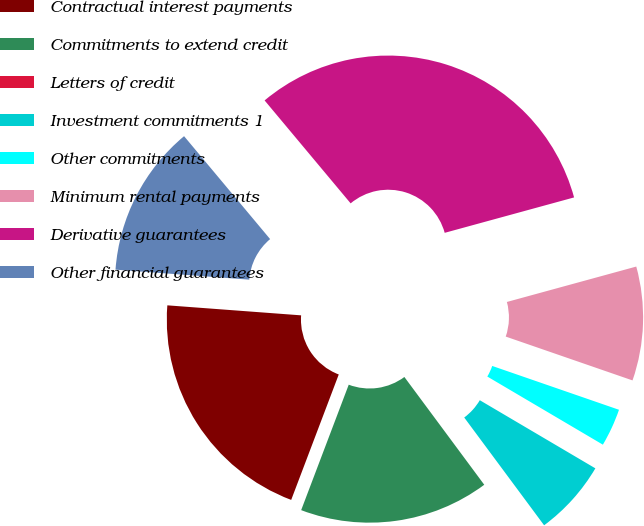<chart> <loc_0><loc_0><loc_500><loc_500><pie_chart><fcel>Contractual interest payments<fcel>Commitments to extend credit<fcel>Letters of credit<fcel>Investment commitments 1<fcel>Other commitments<fcel>Minimum rental payments<fcel>Derivative guarantees<fcel>Other financial guarantees<nl><fcel>20.42%<fcel>15.92%<fcel>0.0%<fcel>6.37%<fcel>3.18%<fcel>9.55%<fcel>31.83%<fcel>12.73%<nl></chart> 